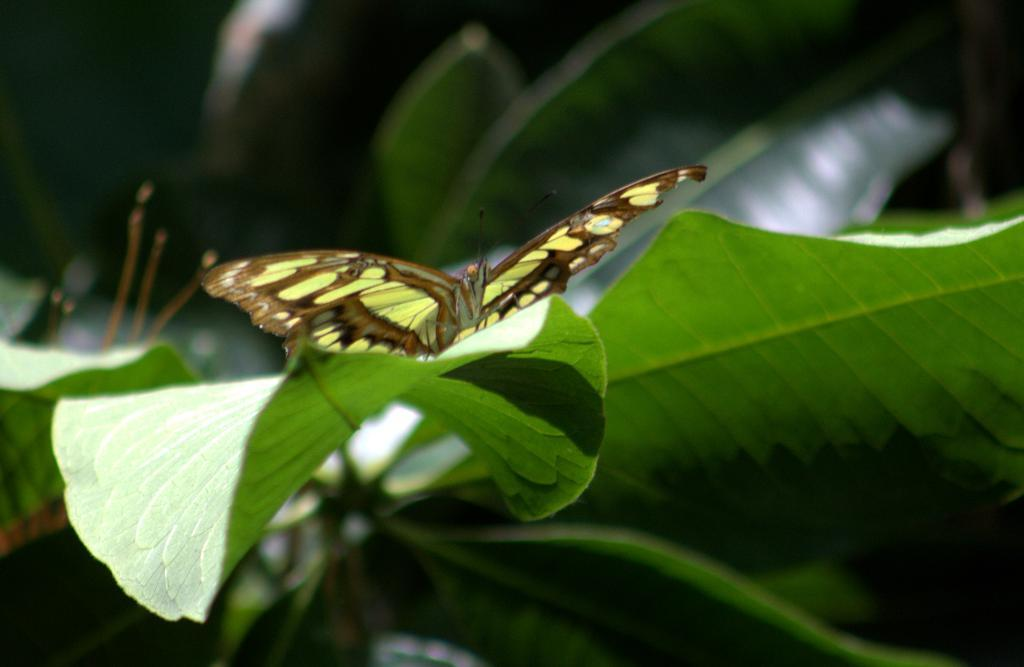What is the main subject of the image? There is a moth in the image. Where is the moth located? The moth is on a green leaf. What type of vegetation is present in the image? There are green leaves in the image. What else can be seen in the background of the image? There are other objects visible in the background of the image. What type of creature is sitting on the tray in the image? There is no tray present in the image, and therefore no creature sitting on it. 